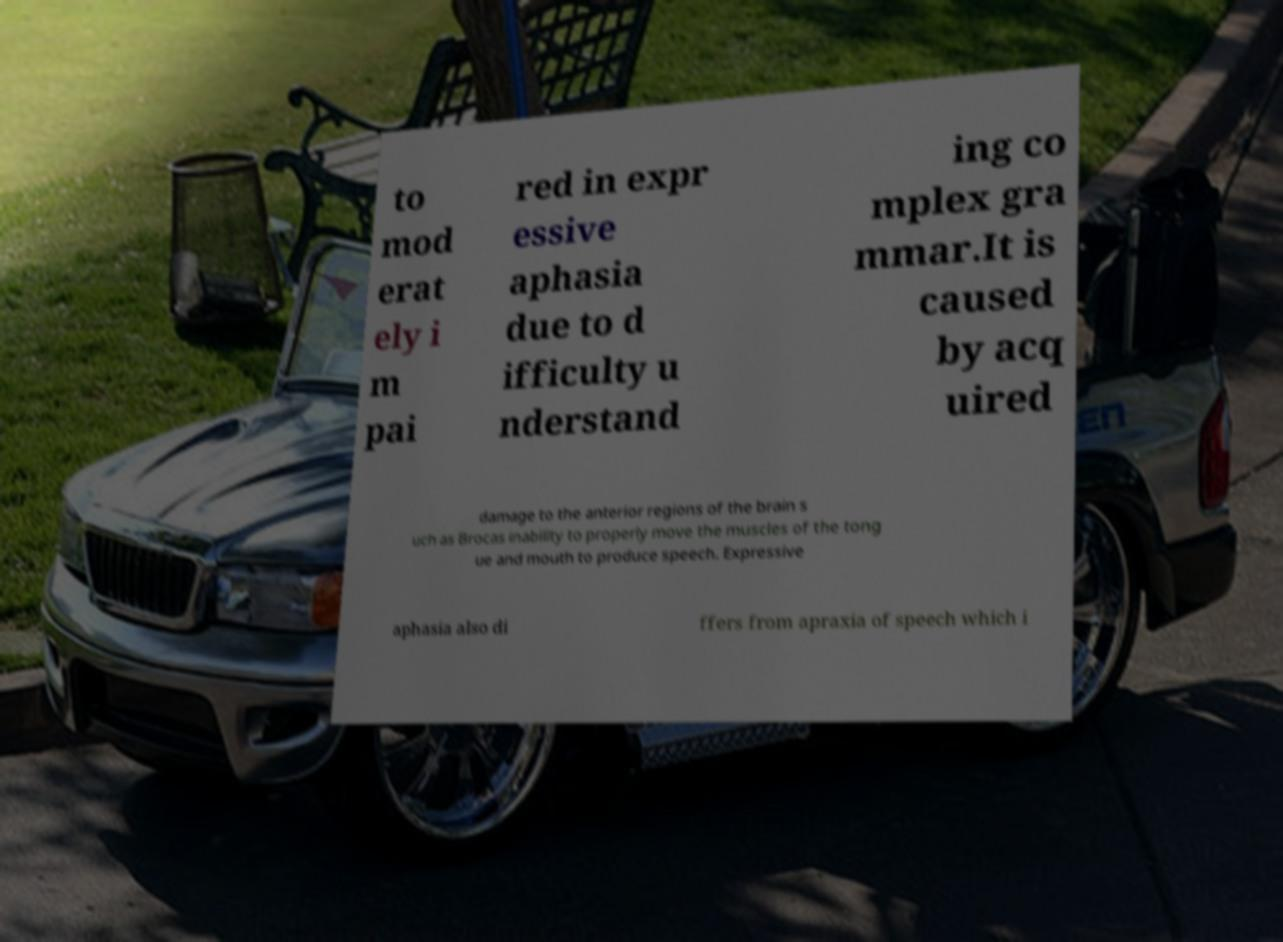Please identify and transcribe the text found in this image. to mod erat ely i m pai red in expr essive aphasia due to d ifficulty u nderstand ing co mplex gra mmar.It is caused by acq uired damage to the anterior regions of the brain s uch as Brocas inability to properly move the muscles of the tong ue and mouth to produce speech. Expressive aphasia also di ffers from apraxia of speech which i 